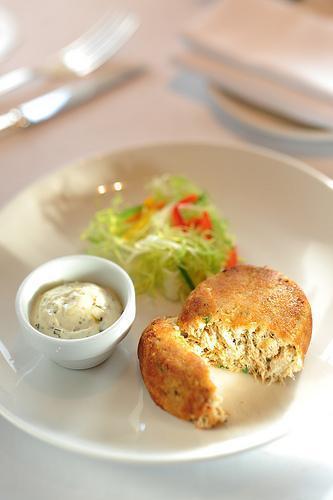How many plates are there?
Give a very brief answer. 1. 